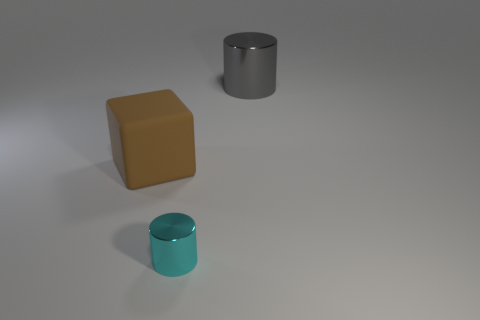The other gray object that is the same shape as the tiny object is what size?
Keep it short and to the point. Large. Is the shape of the object to the right of the cyan shiny cylinder the same as  the big brown rubber thing?
Give a very brief answer. No. Are there any things that have the same size as the gray cylinder?
Give a very brief answer. Yes. There is a thing that is left of the metallic cylinder that is in front of the large metal thing; are there any large gray objects in front of it?
Provide a succinct answer. No. The object that is left of the shiny object that is in front of the metal object behind the small shiny cylinder is made of what material?
Keep it short and to the point. Rubber. The big object to the left of the cyan metallic cylinder has what shape?
Your answer should be very brief. Cube. The object that is the same material as the cyan cylinder is what size?
Keep it short and to the point. Large. How many tiny metal things have the same shape as the big metal thing?
Offer a terse response. 1. Does the big thing that is on the right side of the large matte cube have the same color as the tiny cylinder?
Provide a succinct answer. No. There is a metallic object in front of the shiny cylinder behind the block; how many brown blocks are in front of it?
Ensure brevity in your answer.  0. 